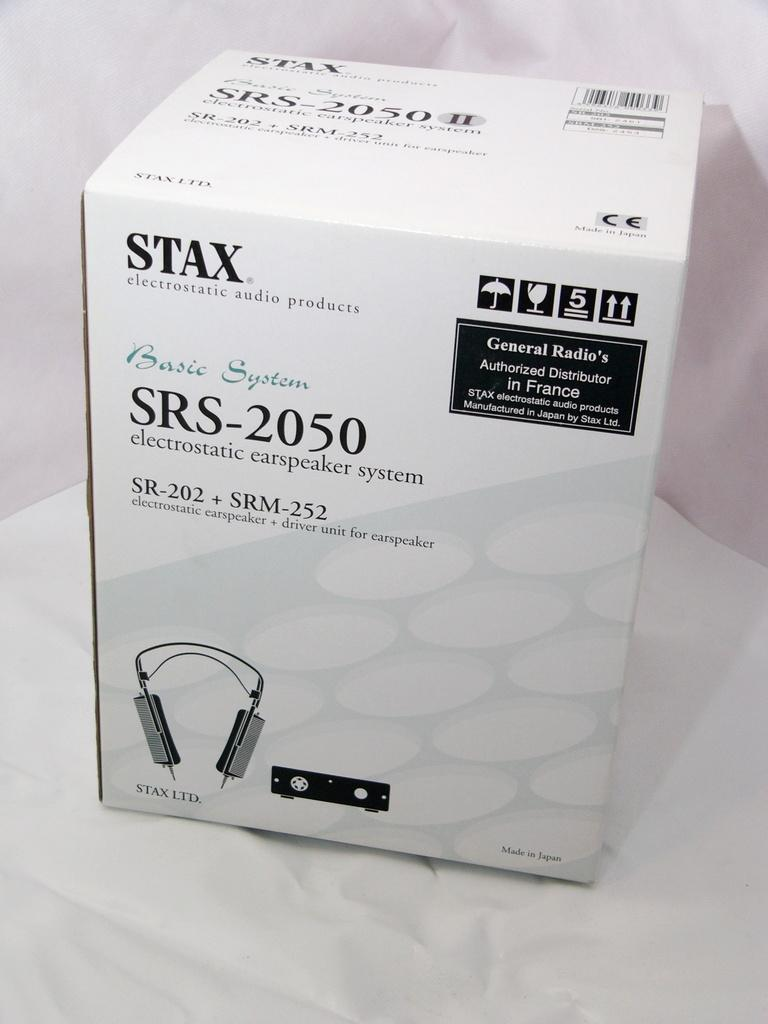Provide a one-sentence caption for the provided image. The box contains a STAX brand carspeaker system. 